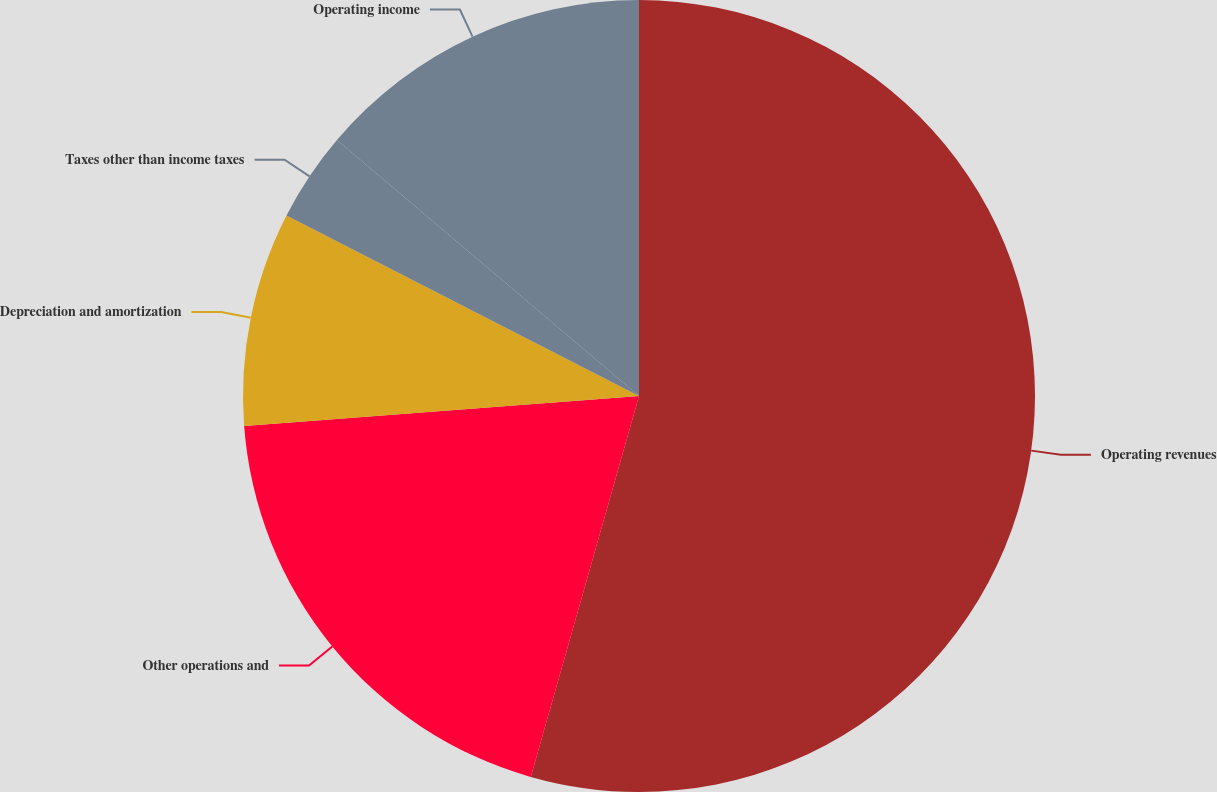Convert chart to OTSL. <chart><loc_0><loc_0><loc_500><loc_500><pie_chart><fcel>Operating revenues<fcel>Other operations and<fcel>Depreciation and amortization<fcel>Taxes other than income taxes<fcel>Operating income<nl><fcel>54.4%<fcel>19.39%<fcel>8.73%<fcel>3.66%<fcel>13.81%<nl></chart> 